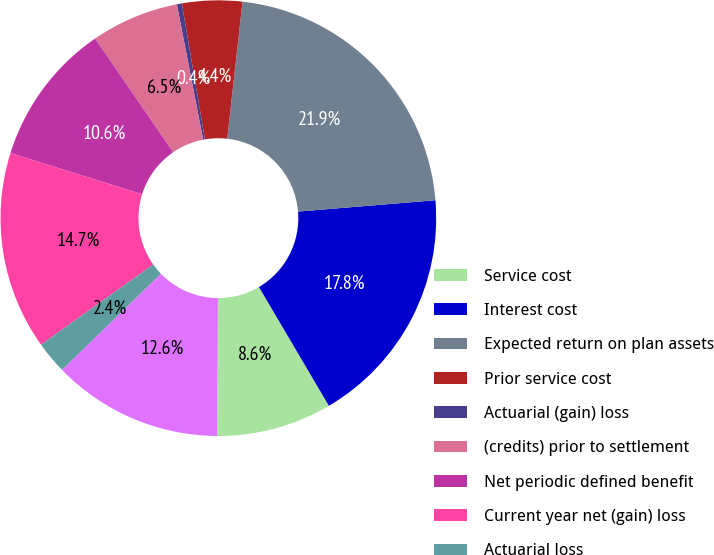Convert chart. <chart><loc_0><loc_0><loc_500><loc_500><pie_chart><fcel>Service cost<fcel>Interest cost<fcel>Expected return on plan assets<fcel>Prior service cost<fcel>Actuarial (gain) loss<fcel>(credits) prior to settlement<fcel>Net periodic defined benefit<fcel>Current year net (gain) loss<fcel>Actuarial loss<fcel>Total recognized in OCI and<nl><fcel>8.56%<fcel>17.84%<fcel>21.92%<fcel>4.45%<fcel>0.37%<fcel>6.52%<fcel>10.6%<fcel>14.69%<fcel>2.41%<fcel>12.64%<nl></chart> 